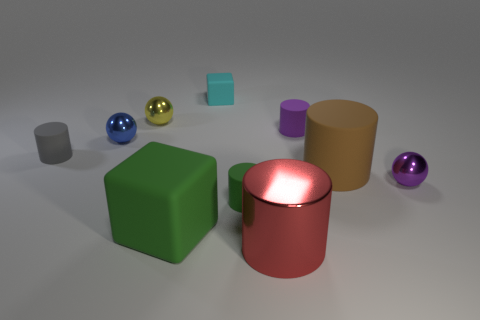Is the number of gray things in front of the big metallic cylinder less than the number of tiny purple matte things on the left side of the green matte block?
Your response must be concise. No. What material is the cylinder to the left of the small metallic sphere that is behind the small blue metallic sphere that is to the left of the brown object?
Your answer should be compact. Rubber. There is a matte thing that is right of the shiny cylinder and on the left side of the large brown matte cylinder; what size is it?
Your answer should be compact. Small. What number of cylinders are either big green matte objects or tiny blue objects?
Keep it short and to the point. 0. There is a rubber block that is the same size as the blue sphere; what color is it?
Your answer should be compact. Cyan. Is there anything else that is the same shape as the big red thing?
Provide a short and direct response. Yes. The big shiny thing that is the same shape as the small gray rubber thing is what color?
Give a very brief answer. Red. How many things are cylinders or cubes that are in front of the small cyan block?
Your answer should be compact. 6. Are there fewer small spheres in front of the large brown cylinder than large red metallic cylinders?
Provide a succinct answer. No. There is a cylinder in front of the green matte thing behind the large matte thing that is in front of the purple metallic ball; what is its size?
Offer a terse response. Large. 